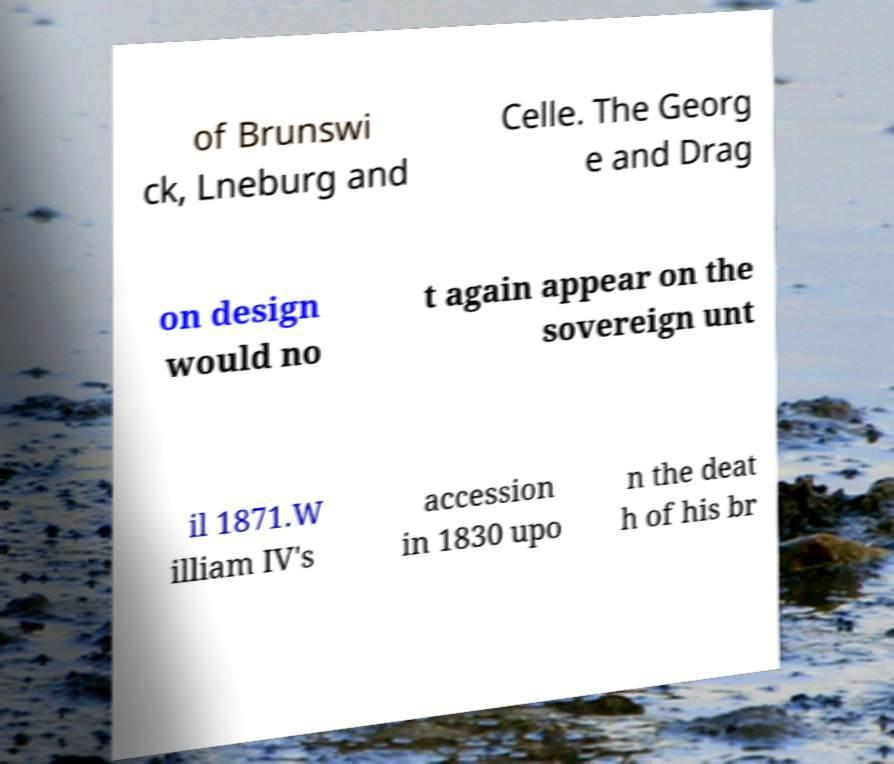Please identify and transcribe the text found in this image. of Brunswi ck, Lneburg and Celle. The Georg e and Drag on design would no t again appear on the sovereign unt il 1871.W illiam IV's accession in 1830 upo n the deat h of his br 